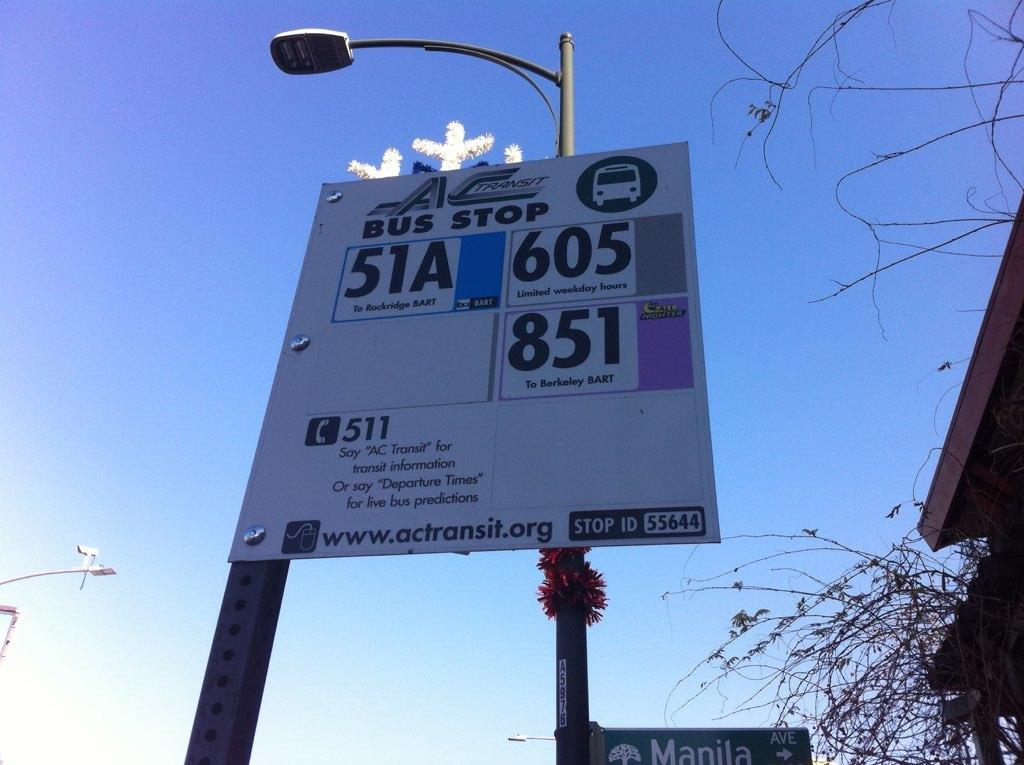<image>
Present a compact description of the photo's key features. A bus stop sign indicates that 51A, 605, and 851 all stop here. 